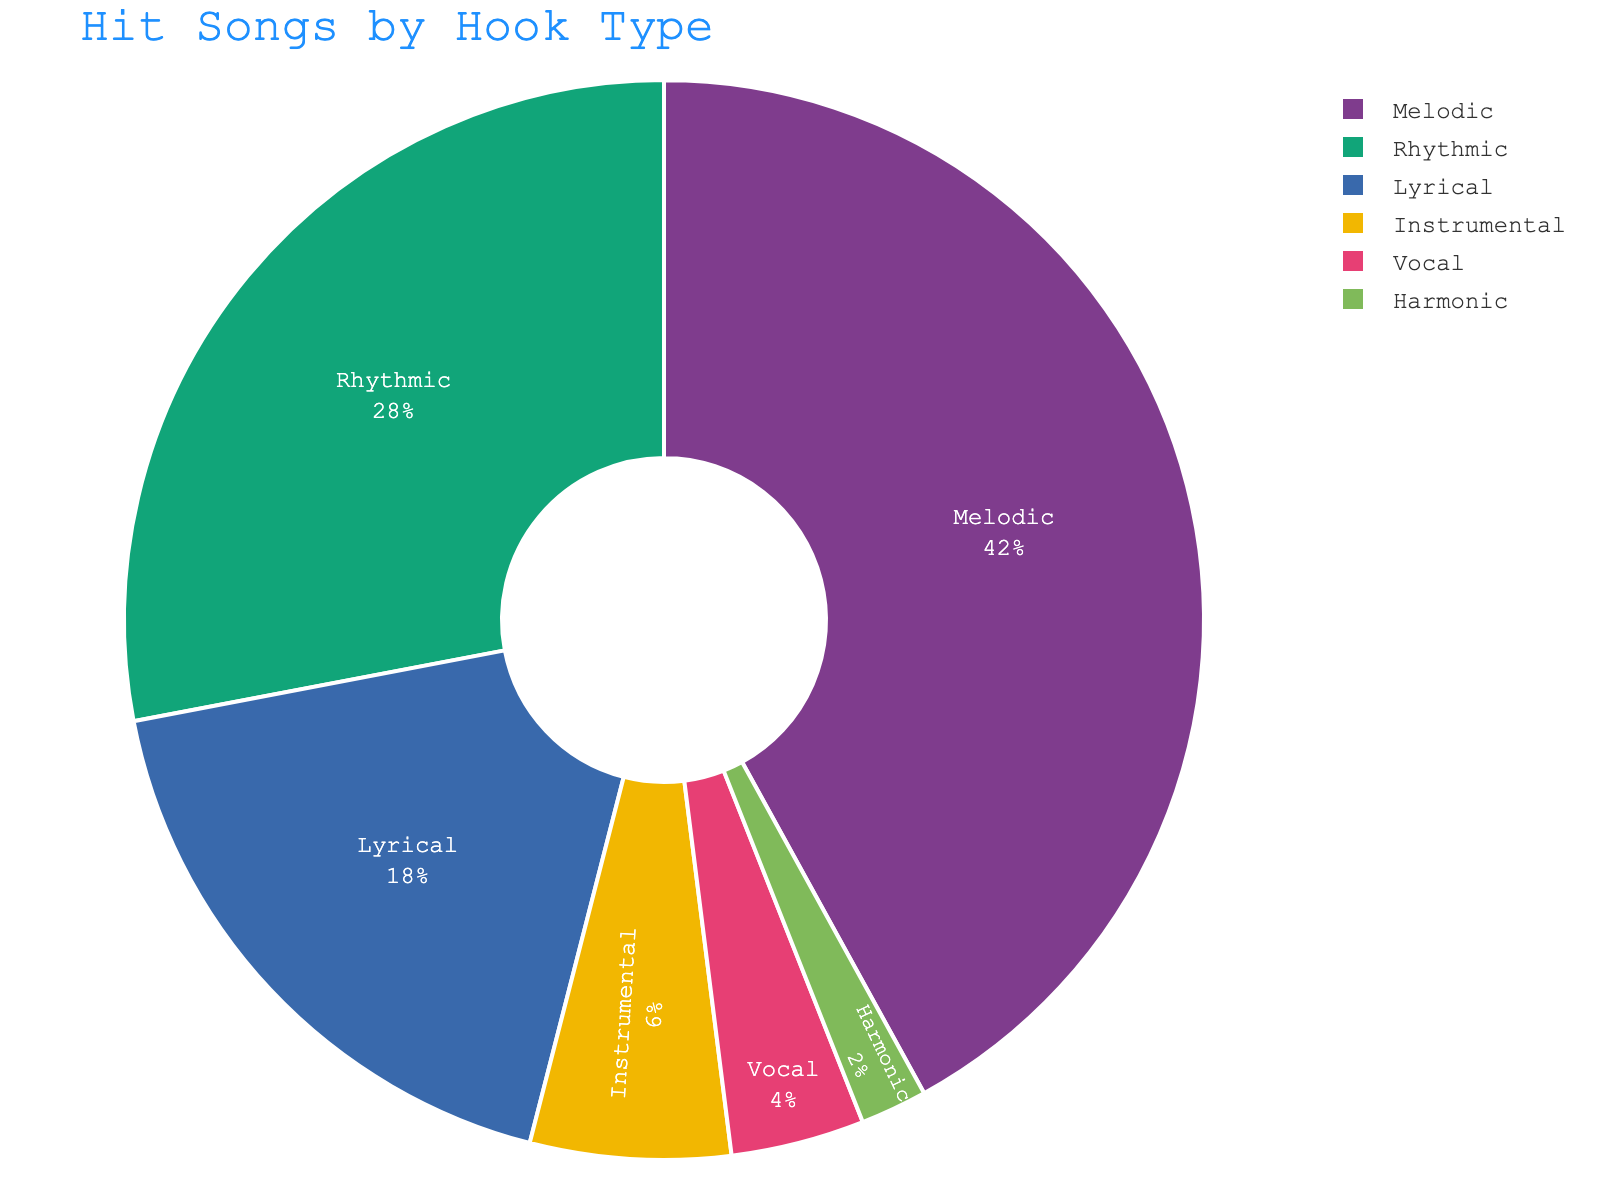What percentage of hit songs have a rhythmic hook? Look for the slice labeled 'Rhythmic' in the pie chart and read the percentage value displayed inside the slice.
Answer: 28% How much more popular are melodic hooks compared to lyrical hooks? Identify and subtract the percentages for 'Lyrical' hooks from 'Melodic' hooks (42% - 18%)
Answer: 24% Which hook type has the smallest share of hit songs? Identify the smallest percentage value on the pie chart; this slice is labeled 'Harmonic'
Answer: Harmonic Which two hook types together make up exactly half of the hit songs? Add the percentages of various combinations; 'Melodic' (42%) and 'Rhythmic' (28%) together make up more than 50%, while 'Melodic' (42%) and 'Lyrical' (18%) exactly sum to 60%. But 'Rhythmic' (28%) and 'Lyrical' (18%) together sum to 46%, closer to half.
Answer: Rhythmic and Lyrical If the 'Instrumental' and 'Vocal' hook types are combined, what percentage of hit songs do they represent? Sum the percentages for 'Instrumental' and 'Vocal' hooks (6% + 4%)
Answer: 10% Do melodic hooks represent more than double the percentage of instrumental hooks? Compare twice the percentage of 'Instrumental' (2 * 6%) with the percentage of 'Melodic' (42%). 2 * 6 is less than 42.
Answer: Yes What proportion of the hit songs do hook types other than 'Melodic' and 'Rhythmic' together represent? Subtract the sum of 'Melodic' and 'Rhythmic' hook percentages from 100 (100% - (42% + 28%))
Answer: 30% Which has a higher percentage: 'Lyrical' hooks or the sum of 'Instrumental' and 'Vocal' hooks? Compare the percentage of 'Lyrical' hooks (18%) with the sum of 'Instrumental' and 'Vocal' hooks (6% + 4% = 10%), hence 18% > 10%
Answer: Lyrical Approximately what fraction of the chart does the 'Harmonic' slice occupy? Identify the percentage of the 'Harmonic' slice (2%) and convert it into a fraction (2/100) which is 1/50.
Answer: 1/50 Are the percentages of 'Instrumental' and 'Vocal' hooks together greater than those of 'Lyrical' hooks individually? Compare the sum of 'Instrumental' and 'Vocal' percentages (6% + 4% = 10%) with the 'Lyrical' percentage (18%); 10% is less than 18%.
Answer: No 